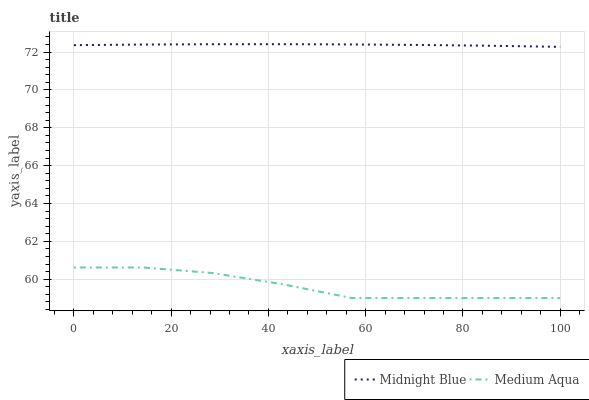Does Medium Aqua have the minimum area under the curve?
Answer yes or no. Yes. Does Midnight Blue have the maximum area under the curve?
Answer yes or no. Yes. Does Midnight Blue have the minimum area under the curve?
Answer yes or no. No. Is Midnight Blue the smoothest?
Answer yes or no. Yes. Is Medium Aqua the roughest?
Answer yes or no. Yes. Is Midnight Blue the roughest?
Answer yes or no. No. Does Medium Aqua have the lowest value?
Answer yes or no. Yes. Does Midnight Blue have the lowest value?
Answer yes or no. No. Does Midnight Blue have the highest value?
Answer yes or no. Yes. Is Medium Aqua less than Midnight Blue?
Answer yes or no. Yes. Is Midnight Blue greater than Medium Aqua?
Answer yes or no. Yes. Does Medium Aqua intersect Midnight Blue?
Answer yes or no. No. 